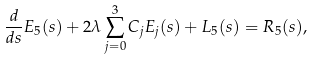<formula> <loc_0><loc_0><loc_500><loc_500>\frac { d } { d s } E _ { 5 } ( s ) + 2 \lambda \sum _ { j = 0 } ^ { 3 } C _ { j } E _ { j } ( s ) + L _ { 5 } ( s ) = R _ { 5 } ( s ) ,</formula> 